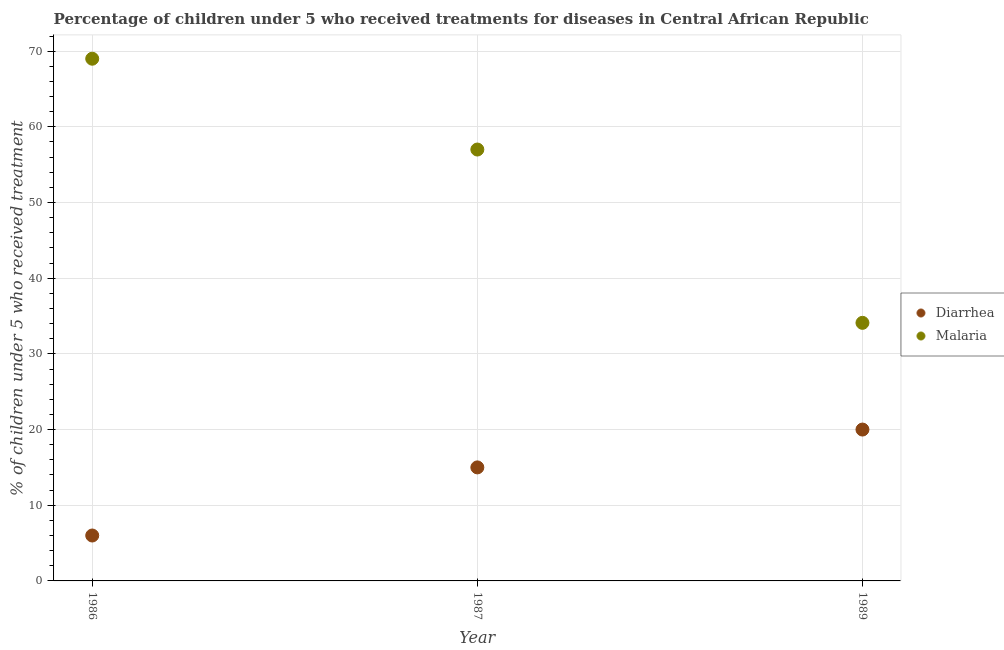Is the number of dotlines equal to the number of legend labels?
Offer a terse response. Yes. What is the percentage of children who received treatment for diarrhoea in 1987?
Your response must be concise. 15. Across all years, what is the maximum percentage of children who received treatment for diarrhoea?
Offer a terse response. 20. Across all years, what is the minimum percentage of children who received treatment for malaria?
Offer a very short reply. 34.1. In which year was the percentage of children who received treatment for diarrhoea maximum?
Provide a short and direct response. 1989. What is the total percentage of children who received treatment for diarrhoea in the graph?
Keep it short and to the point. 41. What is the difference between the percentage of children who received treatment for diarrhoea in 1986 and that in 1987?
Offer a terse response. -9. What is the difference between the percentage of children who received treatment for diarrhoea in 1989 and the percentage of children who received treatment for malaria in 1987?
Your answer should be very brief. -37. What is the average percentage of children who received treatment for diarrhoea per year?
Provide a short and direct response. 13.67. In the year 1986, what is the difference between the percentage of children who received treatment for malaria and percentage of children who received treatment for diarrhoea?
Keep it short and to the point. 63. In how many years, is the percentage of children who received treatment for malaria greater than 18 %?
Ensure brevity in your answer.  3. What is the ratio of the percentage of children who received treatment for diarrhoea in 1986 to that in 1987?
Offer a very short reply. 0.4. What is the difference between the highest and the second highest percentage of children who received treatment for diarrhoea?
Give a very brief answer. 5. What is the difference between the highest and the lowest percentage of children who received treatment for malaria?
Make the answer very short. 34.9. In how many years, is the percentage of children who received treatment for malaria greater than the average percentage of children who received treatment for malaria taken over all years?
Provide a short and direct response. 2. Is the percentage of children who received treatment for diarrhoea strictly less than the percentage of children who received treatment for malaria over the years?
Offer a very short reply. Yes. How many dotlines are there?
Your response must be concise. 2. How many years are there in the graph?
Offer a terse response. 3. Are the values on the major ticks of Y-axis written in scientific E-notation?
Make the answer very short. No. Does the graph contain any zero values?
Your answer should be very brief. No. Where does the legend appear in the graph?
Ensure brevity in your answer.  Center right. How many legend labels are there?
Provide a succinct answer. 2. What is the title of the graph?
Give a very brief answer. Percentage of children under 5 who received treatments for diseases in Central African Republic. Does "Female population" appear as one of the legend labels in the graph?
Provide a short and direct response. No. What is the label or title of the X-axis?
Provide a succinct answer. Year. What is the label or title of the Y-axis?
Provide a short and direct response. % of children under 5 who received treatment. What is the % of children under 5 who received treatment of Malaria in 1986?
Ensure brevity in your answer.  69. What is the % of children under 5 who received treatment of Malaria in 1987?
Offer a terse response. 57. What is the % of children under 5 who received treatment of Diarrhea in 1989?
Provide a short and direct response. 20. What is the % of children under 5 who received treatment of Malaria in 1989?
Your answer should be very brief. 34.1. Across all years, what is the minimum % of children under 5 who received treatment of Diarrhea?
Your response must be concise. 6. Across all years, what is the minimum % of children under 5 who received treatment in Malaria?
Provide a short and direct response. 34.1. What is the total % of children under 5 who received treatment in Malaria in the graph?
Keep it short and to the point. 160.1. What is the difference between the % of children under 5 who received treatment in Diarrhea in 1986 and that in 1987?
Keep it short and to the point. -9. What is the difference between the % of children under 5 who received treatment of Diarrhea in 1986 and that in 1989?
Ensure brevity in your answer.  -14. What is the difference between the % of children under 5 who received treatment in Malaria in 1986 and that in 1989?
Ensure brevity in your answer.  34.9. What is the difference between the % of children under 5 who received treatment of Diarrhea in 1987 and that in 1989?
Provide a succinct answer. -5. What is the difference between the % of children under 5 who received treatment of Malaria in 1987 and that in 1989?
Offer a very short reply. 22.9. What is the difference between the % of children under 5 who received treatment of Diarrhea in 1986 and the % of children under 5 who received treatment of Malaria in 1987?
Provide a short and direct response. -51. What is the difference between the % of children under 5 who received treatment in Diarrhea in 1986 and the % of children under 5 who received treatment in Malaria in 1989?
Provide a succinct answer. -28.1. What is the difference between the % of children under 5 who received treatment of Diarrhea in 1987 and the % of children under 5 who received treatment of Malaria in 1989?
Your answer should be compact. -19.1. What is the average % of children under 5 who received treatment of Diarrhea per year?
Keep it short and to the point. 13.67. What is the average % of children under 5 who received treatment in Malaria per year?
Give a very brief answer. 53.37. In the year 1986, what is the difference between the % of children under 5 who received treatment of Diarrhea and % of children under 5 who received treatment of Malaria?
Ensure brevity in your answer.  -63. In the year 1987, what is the difference between the % of children under 5 who received treatment of Diarrhea and % of children under 5 who received treatment of Malaria?
Offer a very short reply. -42. In the year 1989, what is the difference between the % of children under 5 who received treatment in Diarrhea and % of children under 5 who received treatment in Malaria?
Your answer should be compact. -14.1. What is the ratio of the % of children under 5 who received treatment of Malaria in 1986 to that in 1987?
Give a very brief answer. 1.21. What is the ratio of the % of children under 5 who received treatment of Diarrhea in 1986 to that in 1989?
Your answer should be very brief. 0.3. What is the ratio of the % of children under 5 who received treatment of Malaria in 1986 to that in 1989?
Offer a terse response. 2.02. What is the ratio of the % of children under 5 who received treatment of Malaria in 1987 to that in 1989?
Keep it short and to the point. 1.67. What is the difference between the highest and the second highest % of children under 5 who received treatment in Malaria?
Your response must be concise. 12. What is the difference between the highest and the lowest % of children under 5 who received treatment in Diarrhea?
Your answer should be very brief. 14. What is the difference between the highest and the lowest % of children under 5 who received treatment of Malaria?
Offer a terse response. 34.9. 